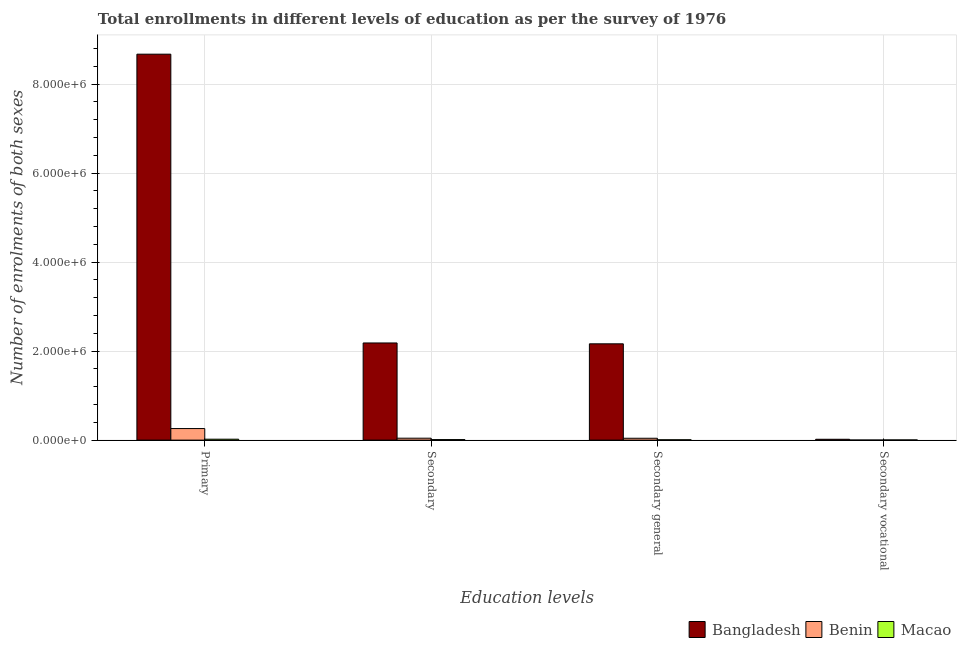How many groups of bars are there?
Offer a very short reply. 4. Are the number of bars on each tick of the X-axis equal?
Ensure brevity in your answer.  Yes. How many bars are there on the 2nd tick from the right?
Provide a succinct answer. 3. What is the label of the 2nd group of bars from the left?
Your answer should be compact. Secondary. What is the number of enrolments in secondary vocational education in Bangladesh?
Your answer should be very brief. 1.91e+04. Across all countries, what is the maximum number of enrolments in secondary education?
Keep it short and to the point. 2.18e+06. Across all countries, what is the minimum number of enrolments in secondary general education?
Give a very brief answer. 7867. In which country was the number of enrolments in secondary education minimum?
Keep it short and to the point. Macao. What is the total number of enrolments in secondary education in the graph?
Your response must be concise. 2.24e+06. What is the difference between the number of enrolments in primary education in Bangladesh and that in Benin?
Offer a terse response. 8.41e+06. What is the difference between the number of enrolments in secondary vocational education in Benin and the number of enrolments in secondary education in Bangladesh?
Ensure brevity in your answer.  -2.18e+06. What is the average number of enrolments in primary education per country?
Offer a terse response. 2.98e+06. What is the difference between the number of enrolments in secondary general education and number of enrolments in primary education in Bangladesh?
Keep it short and to the point. -6.51e+06. In how many countries, is the number of enrolments in primary education greater than 1600000 ?
Your answer should be compact. 1. What is the ratio of the number of enrolments in primary education in Macao to that in Bangladesh?
Your answer should be very brief. 0. What is the difference between the highest and the second highest number of enrolments in secondary education?
Offer a very short reply. 2.14e+06. What is the difference between the highest and the lowest number of enrolments in secondary general education?
Give a very brief answer. 2.16e+06. What does the 3rd bar from the left in Secondary vocational represents?
Give a very brief answer. Macao. What does the 1st bar from the right in Secondary general represents?
Your response must be concise. Macao. Is it the case that in every country, the sum of the number of enrolments in primary education and number of enrolments in secondary education is greater than the number of enrolments in secondary general education?
Provide a succinct answer. Yes. Are all the bars in the graph horizontal?
Offer a terse response. No. What is the difference between two consecutive major ticks on the Y-axis?
Make the answer very short. 2.00e+06. Are the values on the major ticks of Y-axis written in scientific E-notation?
Your answer should be very brief. Yes. Does the graph contain grids?
Make the answer very short. Yes. How many legend labels are there?
Provide a succinct answer. 3. How are the legend labels stacked?
Your response must be concise. Horizontal. What is the title of the graph?
Offer a very short reply. Total enrollments in different levels of education as per the survey of 1976. Does "Iceland" appear as one of the legend labels in the graph?
Make the answer very short. No. What is the label or title of the X-axis?
Keep it short and to the point. Education levels. What is the label or title of the Y-axis?
Offer a very short reply. Number of enrolments of both sexes. What is the Number of enrolments of both sexes in Bangladesh in Primary?
Your response must be concise. 8.67e+06. What is the Number of enrolments of both sexes of Benin in Primary?
Offer a very short reply. 2.60e+05. What is the Number of enrolments of both sexes in Macao in Primary?
Offer a terse response. 2.08e+04. What is the Number of enrolments of both sexes of Bangladesh in Secondary?
Provide a succinct answer. 2.18e+06. What is the Number of enrolments of both sexes of Benin in Secondary?
Provide a succinct answer. 4.31e+04. What is the Number of enrolments of both sexes in Macao in Secondary?
Provide a succinct answer. 1.18e+04. What is the Number of enrolments of both sexes in Bangladesh in Secondary general?
Offer a terse response. 2.16e+06. What is the Number of enrolments of both sexes of Benin in Secondary general?
Your answer should be compact. 4.18e+04. What is the Number of enrolments of both sexes in Macao in Secondary general?
Provide a short and direct response. 7867. What is the Number of enrolments of both sexes of Bangladesh in Secondary vocational?
Your answer should be compact. 1.91e+04. What is the Number of enrolments of both sexes of Benin in Secondary vocational?
Ensure brevity in your answer.  1321. What is the Number of enrolments of both sexes in Macao in Secondary vocational?
Your answer should be compact. 3891. Across all Education levels, what is the maximum Number of enrolments of both sexes of Bangladesh?
Your response must be concise. 8.67e+06. Across all Education levels, what is the maximum Number of enrolments of both sexes of Benin?
Offer a very short reply. 2.60e+05. Across all Education levels, what is the maximum Number of enrolments of both sexes in Macao?
Ensure brevity in your answer.  2.08e+04. Across all Education levels, what is the minimum Number of enrolments of both sexes of Bangladesh?
Make the answer very short. 1.91e+04. Across all Education levels, what is the minimum Number of enrolments of both sexes of Benin?
Make the answer very short. 1321. Across all Education levels, what is the minimum Number of enrolments of both sexes of Macao?
Provide a short and direct response. 3891. What is the total Number of enrolments of both sexes in Bangladesh in the graph?
Ensure brevity in your answer.  1.30e+07. What is the total Number of enrolments of both sexes of Benin in the graph?
Your response must be concise. 3.46e+05. What is the total Number of enrolments of both sexes in Macao in the graph?
Your response must be concise. 4.43e+04. What is the difference between the Number of enrolments of both sexes of Bangladesh in Primary and that in Secondary?
Provide a short and direct response. 6.49e+06. What is the difference between the Number of enrolments of both sexes of Benin in Primary and that in Secondary?
Your answer should be compact. 2.17e+05. What is the difference between the Number of enrolments of both sexes in Macao in Primary and that in Secondary?
Your answer should be very brief. 9000. What is the difference between the Number of enrolments of both sexes of Bangladesh in Primary and that in Secondary general?
Offer a terse response. 6.51e+06. What is the difference between the Number of enrolments of both sexes in Benin in Primary and that in Secondary general?
Your answer should be very brief. 2.18e+05. What is the difference between the Number of enrolments of both sexes in Macao in Primary and that in Secondary general?
Offer a very short reply. 1.29e+04. What is the difference between the Number of enrolments of both sexes in Bangladesh in Primary and that in Secondary vocational?
Your response must be concise. 8.65e+06. What is the difference between the Number of enrolments of both sexes of Benin in Primary and that in Secondary vocational?
Provide a short and direct response. 2.59e+05. What is the difference between the Number of enrolments of both sexes of Macao in Primary and that in Secondary vocational?
Provide a short and direct response. 1.69e+04. What is the difference between the Number of enrolments of both sexes in Bangladesh in Secondary and that in Secondary general?
Keep it short and to the point. 1.91e+04. What is the difference between the Number of enrolments of both sexes in Benin in Secondary and that in Secondary general?
Give a very brief answer. 1321. What is the difference between the Number of enrolments of both sexes of Macao in Secondary and that in Secondary general?
Offer a terse response. 3891. What is the difference between the Number of enrolments of both sexes of Bangladesh in Secondary and that in Secondary vocational?
Ensure brevity in your answer.  2.16e+06. What is the difference between the Number of enrolments of both sexes in Benin in Secondary and that in Secondary vocational?
Provide a succinct answer. 4.18e+04. What is the difference between the Number of enrolments of both sexes of Macao in Secondary and that in Secondary vocational?
Your answer should be compact. 7867. What is the difference between the Number of enrolments of both sexes of Bangladesh in Secondary general and that in Secondary vocational?
Provide a short and direct response. 2.15e+06. What is the difference between the Number of enrolments of both sexes of Benin in Secondary general and that in Secondary vocational?
Your answer should be very brief. 4.05e+04. What is the difference between the Number of enrolments of both sexes of Macao in Secondary general and that in Secondary vocational?
Keep it short and to the point. 3976. What is the difference between the Number of enrolments of both sexes of Bangladesh in Primary and the Number of enrolments of both sexes of Benin in Secondary?
Your response must be concise. 8.63e+06. What is the difference between the Number of enrolments of both sexes in Bangladesh in Primary and the Number of enrolments of both sexes in Macao in Secondary?
Provide a succinct answer. 8.66e+06. What is the difference between the Number of enrolments of both sexes of Benin in Primary and the Number of enrolments of both sexes of Macao in Secondary?
Keep it short and to the point. 2.48e+05. What is the difference between the Number of enrolments of both sexes in Bangladesh in Primary and the Number of enrolments of both sexes in Benin in Secondary general?
Give a very brief answer. 8.63e+06. What is the difference between the Number of enrolments of both sexes in Bangladesh in Primary and the Number of enrolments of both sexes in Macao in Secondary general?
Give a very brief answer. 8.67e+06. What is the difference between the Number of enrolments of both sexes in Benin in Primary and the Number of enrolments of both sexes in Macao in Secondary general?
Keep it short and to the point. 2.52e+05. What is the difference between the Number of enrolments of both sexes in Bangladesh in Primary and the Number of enrolments of both sexes in Benin in Secondary vocational?
Ensure brevity in your answer.  8.67e+06. What is the difference between the Number of enrolments of both sexes of Bangladesh in Primary and the Number of enrolments of both sexes of Macao in Secondary vocational?
Provide a short and direct response. 8.67e+06. What is the difference between the Number of enrolments of both sexes in Benin in Primary and the Number of enrolments of both sexes in Macao in Secondary vocational?
Offer a terse response. 2.56e+05. What is the difference between the Number of enrolments of both sexes in Bangladesh in Secondary and the Number of enrolments of both sexes in Benin in Secondary general?
Provide a succinct answer. 2.14e+06. What is the difference between the Number of enrolments of both sexes of Bangladesh in Secondary and the Number of enrolments of both sexes of Macao in Secondary general?
Ensure brevity in your answer.  2.18e+06. What is the difference between the Number of enrolments of both sexes in Benin in Secondary and the Number of enrolments of both sexes in Macao in Secondary general?
Give a very brief answer. 3.53e+04. What is the difference between the Number of enrolments of both sexes of Bangladesh in Secondary and the Number of enrolments of both sexes of Benin in Secondary vocational?
Provide a succinct answer. 2.18e+06. What is the difference between the Number of enrolments of both sexes in Bangladesh in Secondary and the Number of enrolments of both sexes in Macao in Secondary vocational?
Provide a short and direct response. 2.18e+06. What is the difference between the Number of enrolments of both sexes in Benin in Secondary and the Number of enrolments of both sexes in Macao in Secondary vocational?
Offer a terse response. 3.92e+04. What is the difference between the Number of enrolments of both sexes of Bangladesh in Secondary general and the Number of enrolments of both sexes of Benin in Secondary vocational?
Give a very brief answer. 2.16e+06. What is the difference between the Number of enrolments of both sexes of Bangladesh in Secondary general and the Number of enrolments of both sexes of Macao in Secondary vocational?
Your answer should be very brief. 2.16e+06. What is the difference between the Number of enrolments of both sexes in Benin in Secondary general and the Number of enrolments of both sexes in Macao in Secondary vocational?
Your response must be concise. 3.79e+04. What is the average Number of enrolments of both sexes of Bangladesh per Education levels?
Your answer should be compact. 3.26e+06. What is the average Number of enrolments of both sexes of Benin per Education levels?
Ensure brevity in your answer.  8.65e+04. What is the average Number of enrolments of both sexes of Macao per Education levels?
Your answer should be compact. 1.11e+04. What is the difference between the Number of enrolments of both sexes in Bangladesh and Number of enrolments of both sexes in Benin in Primary?
Give a very brief answer. 8.41e+06. What is the difference between the Number of enrolments of both sexes in Bangladesh and Number of enrolments of both sexes in Macao in Primary?
Provide a short and direct response. 8.65e+06. What is the difference between the Number of enrolments of both sexes of Benin and Number of enrolments of both sexes of Macao in Primary?
Provide a short and direct response. 2.39e+05. What is the difference between the Number of enrolments of both sexes in Bangladesh and Number of enrolments of both sexes in Benin in Secondary?
Offer a terse response. 2.14e+06. What is the difference between the Number of enrolments of both sexes of Bangladesh and Number of enrolments of both sexes of Macao in Secondary?
Offer a terse response. 2.17e+06. What is the difference between the Number of enrolments of both sexes in Benin and Number of enrolments of both sexes in Macao in Secondary?
Offer a very short reply. 3.14e+04. What is the difference between the Number of enrolments of both sexes in Bangladesh and Number of enrolments of both sexes in Benin in Secondary general?
Make the answer very short. 2.12e+06. What is the difference between the Number of enrolments of both sexes of Bangladesh and Number of enrolments of both sexes of Macao in Secondary general?
Provide a short and direct response. 2.16e+06. What is the difference between the Number of enrolments of both sexes of Benin and Number of enrolments of both sexes of Macao in Secondary general?
Provide a succinct answer. 3.39e+04. What is the difference between the Number of enrolments of both sexes in Bangladesh and Number of enrolments of both sexes in Benin in Secondary vocational?
Provide a succinct answer. 1.78e+04. What is the difference between the Number of enrolments of both sexes in Bangladesh and Number of enrolments of both sexes in Macao in Secondary vocational?
Your response must be concise. 1.52e+04. What is the difference between the Number of enrolments of both sexes of Benin and Number of enrolments of both sexes of Macao in Secondary vocational?
Offer a very short reply. -2570. What is the ratio of the Number of enrolments of both sexes in Bangladesh in Primary to that in Secondary?
Keep it short and to the point. 3.97. What is the ratio of the Number of enrolments of both sexes of Benin in Primary to that in Secondary?
Your answer should be compact. 6.03. What is the ratio of the Number of enrolments of both sexes in Macao in Primary to that in Secondary?
Offer a terse response. 1.77. What is the ratio of the Number of enrolments of both sexes of Bangladesh in Primary to that in Secondary general?
Make the answer very short. 4.01. What is the ratio of the Number of enrolments of both sexes in Benin in Primary to that in Secondary general?
Your response must be concise. 6.22. What is the ratio of the Number of enrolments of both sexes in Macao in Primary to that in Secondary general?
Offer a very short reply. 2.64. What is the ratio of the Number of enrolments of both sexes of Bangladesh in Primary to that in Secondary vocational?
Keep it short and to the point. 454.49. What is the ratio of the Number of enrolments of both sexes of Benin in Primary to that in Secondary vocational?
Your answer should be compact. 196.73. What is the ratio of the Number of enrolments of both sexes of Macao in Primary to that in Secondary vocational?
Make the answer very short. 5.33. What is the ratio of the Number of enrolments of both sexes of Bangladesh in Secondary to that in Secondary general?
Make the answer very short. 1.01. What is the ratio of the Number of enrolments of both sexes in Benin in Secondary to that in Secondary general?
Keep it short and to the point. 1.03. What is the ratio of the Number of enrolments of both sexes of Macao in Secondary to that in Secondary general?
Give a very brief answer. 1.49. What is the ratio of the Number of enrolments of both sexes of Bangladesh in Secondary to that in Secondary vocational?
Your response must be concise. 114.4. What is the ratio of the Number of enrolments of both sexes in Benin in Secondary to that in Secondary vocational?
Your answer should be compact. 32.64. What is the ratio of the Number of enrolments of both sexes of Macao in Secondary to that in Secondary vocational?
Provide a short and direct response. 3.02. What is the ratio of the Number of enrolments of both sexes in Bangladesh in Secondary general to that in Secondary vocational?
Provide a succinct answer. 113.4. What is the ratio of the Number of enrolments of both sexes in Benin in Secondary general to that in Secondary vocational?
Provide a succinct answer. 31.64. What is the ratio of the Number of enrolments of both sexes of Macao in Secondary general to that in Secondary vocational?
Provide a short and direct response. 2.02. What is the difference between the highest and the second highest Number of enrolments of both sexes of Bangladesh?
Your answer should be compact. 6.49e+06. What is the difference between the highest and the second highest Number of enrolments of both sexes of Benin?
Provide a short and direct response. 2.17e+05. What is the difference between the highest and the second highest Number of enrolments of both sexes of Macao?
Keep it short and to the point. 9000. What is the difference between the highest and the lowest Number of enrolments of both sexes of Bangladesh?
Provide a short and direct response. 8.65e+06. What is the difference between the highest and the lowest Number of enrolments of both sexes in Benin?
Make the answer very short. 2.59e+05. What is the difference between the highest and the lowest Number of enrolments of both sexes in Macao?
Offer a very short reply. 1.69e+04. 